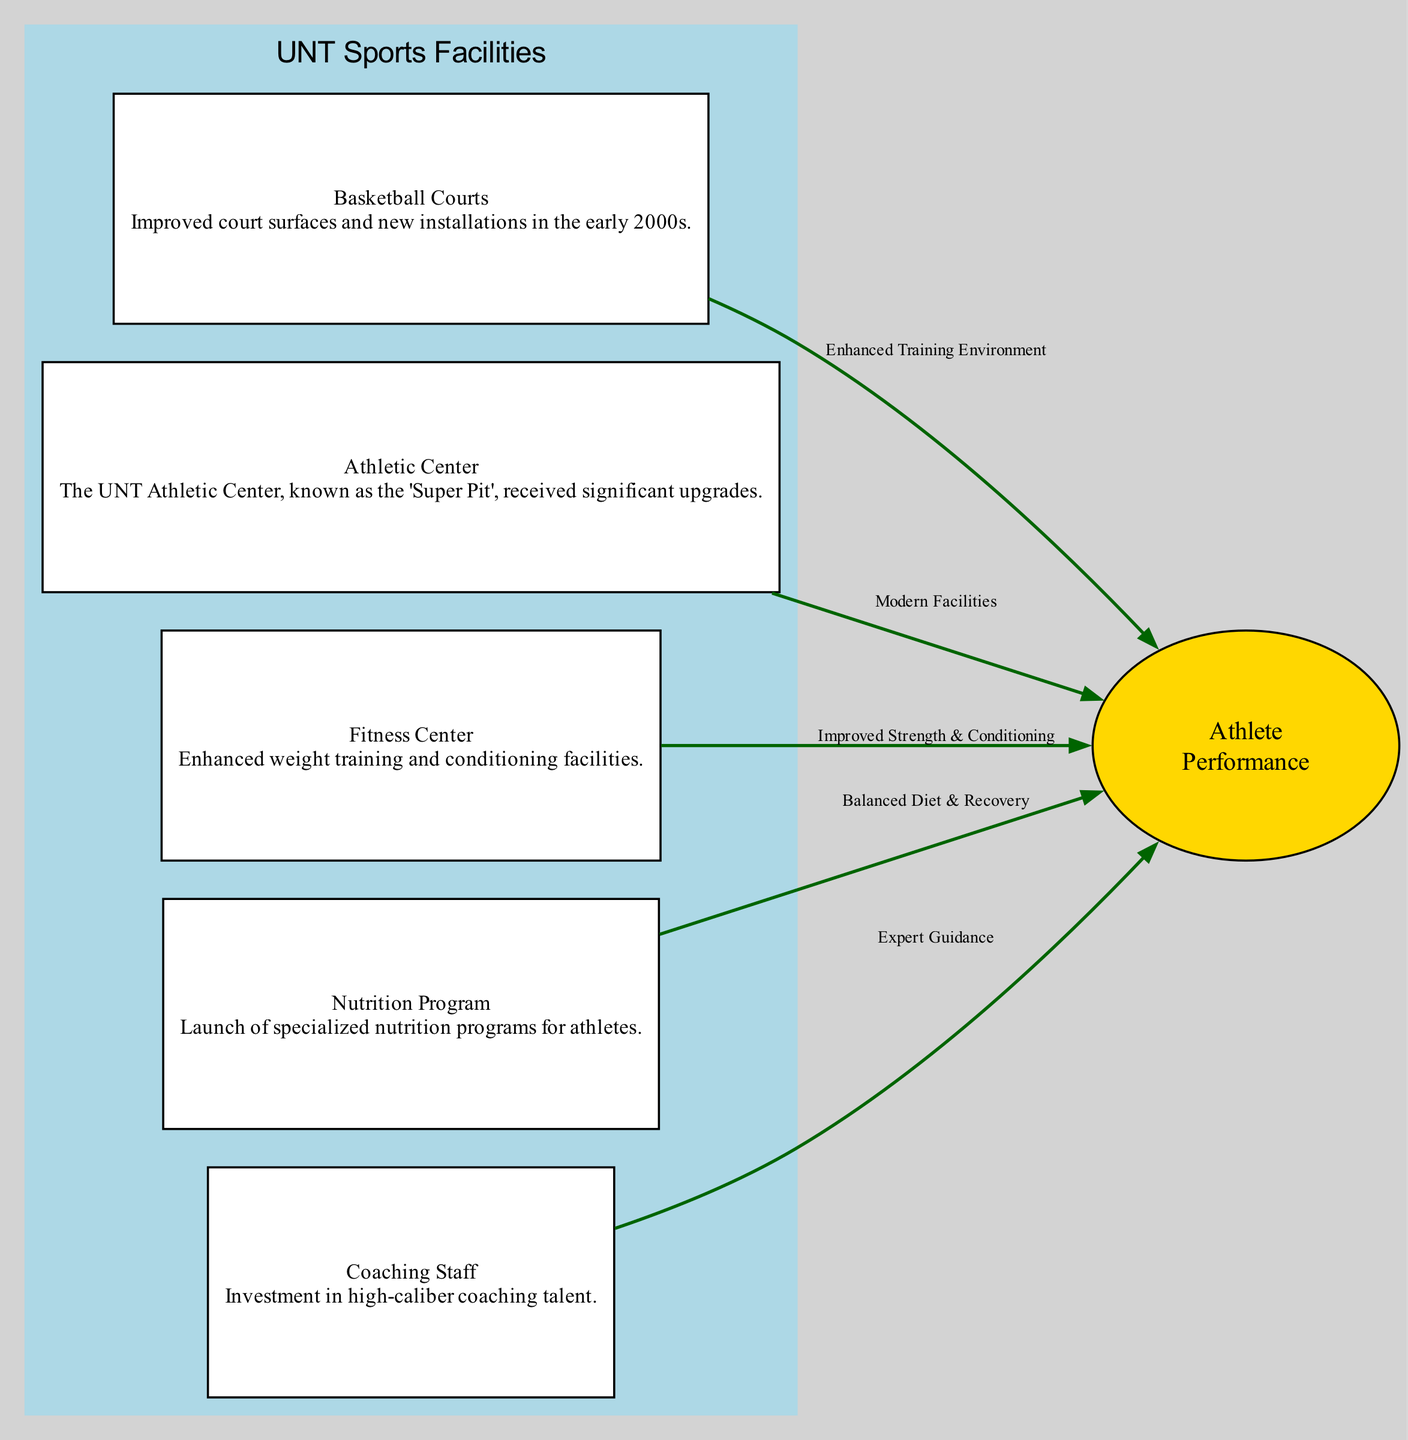What are the two types of facilities included in this diagram? The diagram includes basketball courts and the athletic center as two facilities contributing to athlete performance improvement. They are specifically marked as distinct nodes in the diagram.
Answer: basketball courts, athletic center How many total nodes are there in the diagram? To find the total number of nodes, we count each unique facility depicted in the diagram and the athlete performance node as well. There are five facilities plus one athlete performance node, which totals six nodes.
Answer: 6 Which facility contributes to athlete performance through a balanced diet and recovery? The node labeled "Nutrition Program" is specifically connected to athlete performance through the edge that describes its impact as a balanced diet and recovery. This connection is indicated visually in the diagram by the labeled edge.
Answer: Nutrition Program What is the role of the coaching staff in relation to athlete performance? The coaching staff influences athlete performance by providing expert guidance, as indicated by the directed edge from the coaching staff node to the athlete performance node in the diagram.
Answer: Expert Guidance How many edges exist that connect the facilities to athlete performance? The edges represent relationships between the facilities and athlete performance. By counting each directed edge leading to the athlete performance node from different facilities, we see there are five edges connecting them.
Answer: 5 What improvement does the fitness center provide to athlete performance? The fitness center contributes to athlete performance by improving strength and conditioning, which is specified by the label on the edge connecting the fitness center to the athlete performance node.
Answer: Improved Strength & Conditioning What is the significant upgrade made to the athletic center? The significant upgrade made to the athletic center is indicated in the description as "The UNT Athletic Center, known as the 'Super Pit', received significant upgrades," referring specifically to modernization to support athlete performance.
Answer: Significant upgrades How do the basketball courts enhance the training environment for athletes? The basketball courts enhance the training environment by providing improved court surfaces and new installations that benefit athlete performance, evidenced in the diagram by the edge linking it to athlete performance labeled "Enhanced Training Environment."
Answer: Enhanced Training Environment 